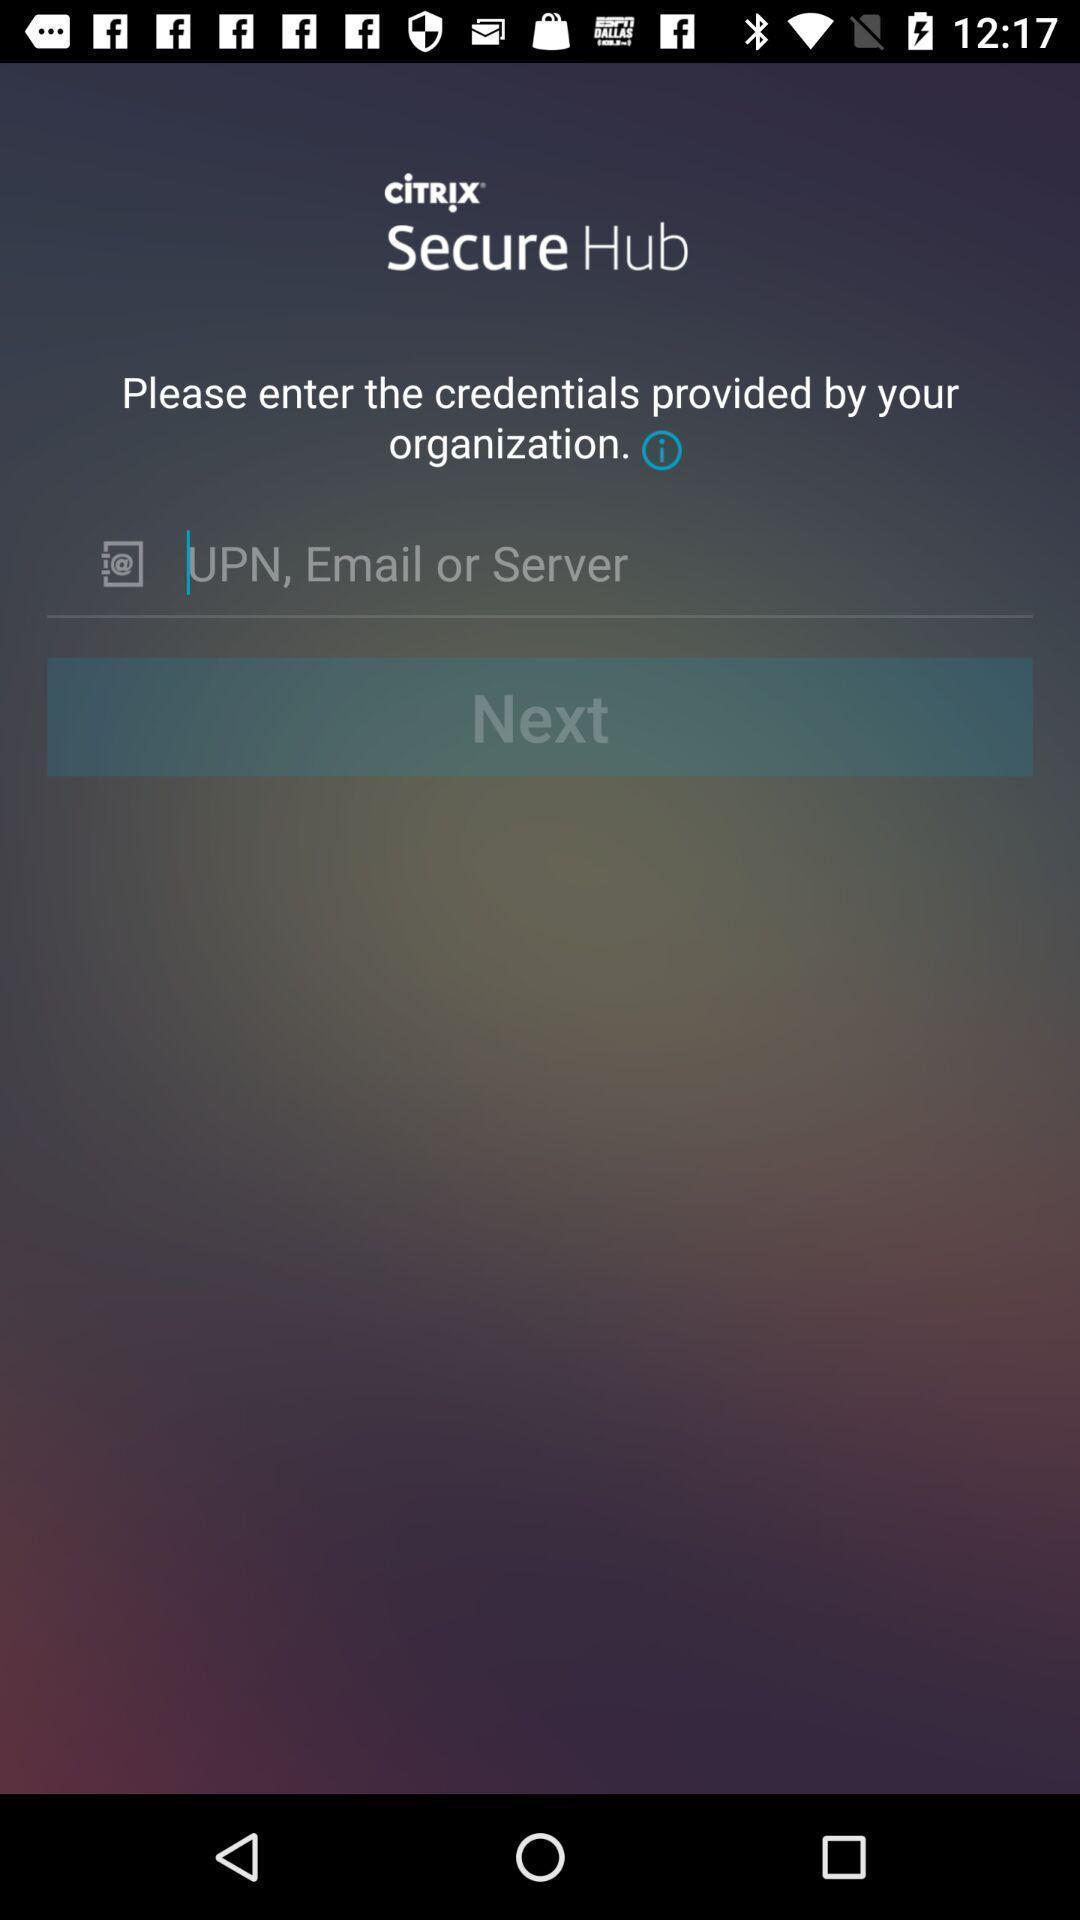What can you discern from this picture? Screen showing enter credentials option. 